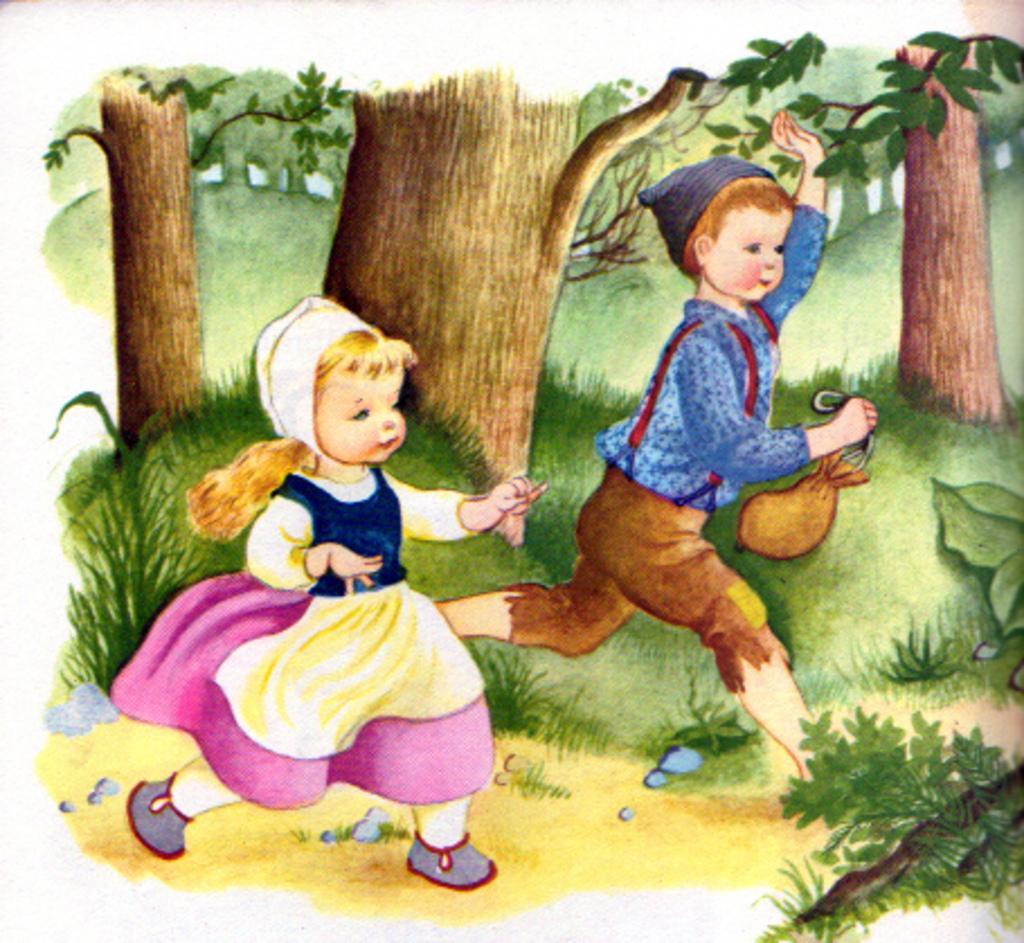How would you summarize this image in a sentence or two? This is a picture of painting. In this picture we can see the tree trunks, leaves, plants and green grass. We can see a girl and a boy. We can see a boy wore a cap and he is holding an object. They both are walking. 